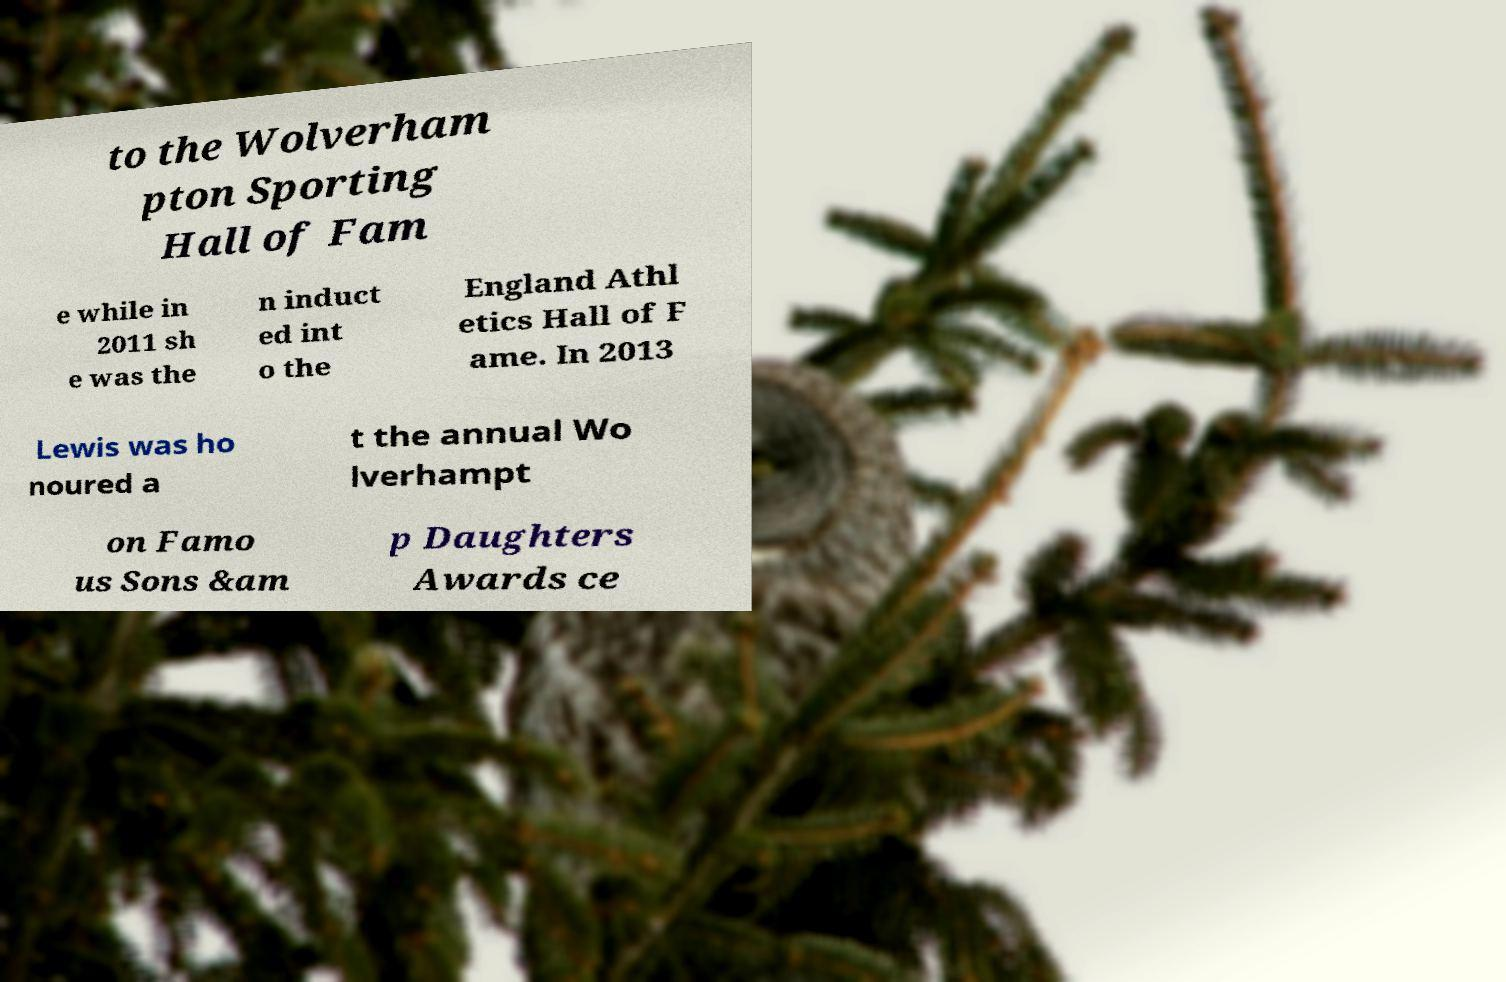Could you assist in decoding the text presented in this image and type it out clearly? to the Wolverham pton Sporting Hall of Fam e while in 2011 sh e was the n induct ed int o the England Athl etics Hall of F ame. In 2013 Lewis was ho noured a t the annual Wo lverhampt on Famo us Sons &am p Daughters Awards ce 